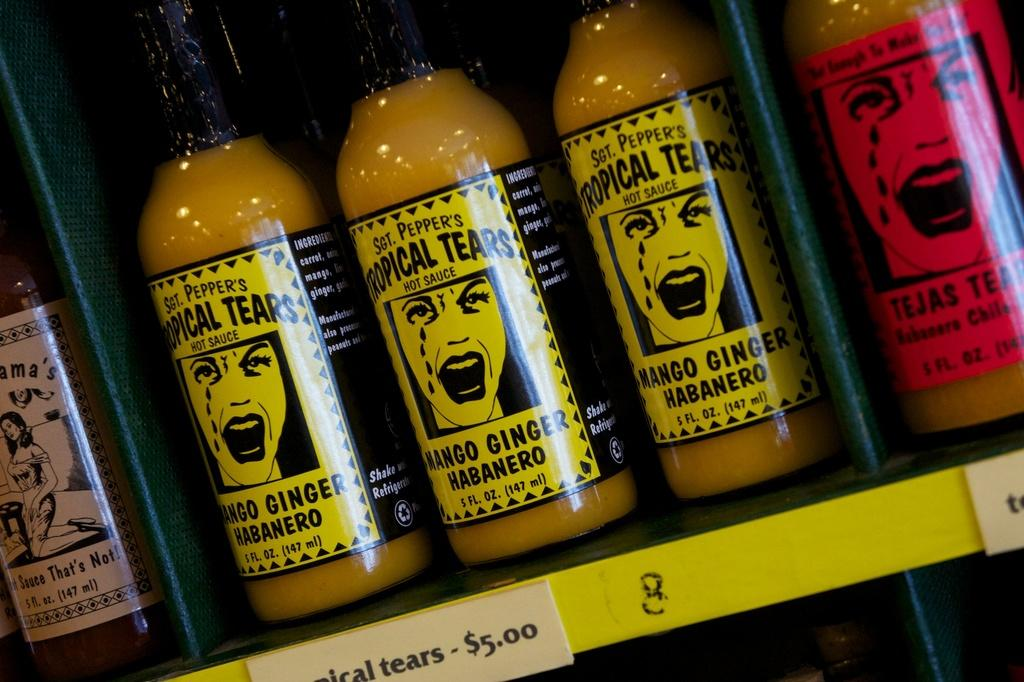<image>
Relay a brief, clear account of the picture shown. A set of tropical tears habanero pepper are in the rack. 